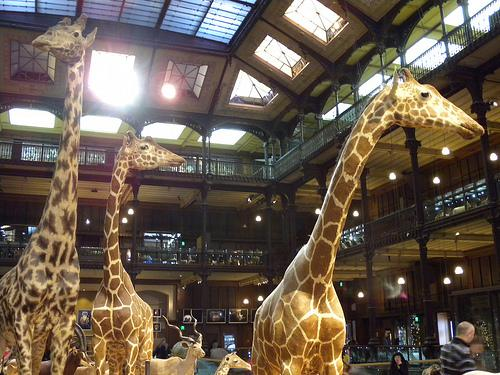Question: what design are the giraffes covered in?
Choices:
A. Spots.
B. Stripes.
C. Polka Dots.
D. Solid.
Answer with the letter. Answer: A Question: how many giraffes are in this photo?
Choices:
A. Three.
B. Two.
C. One.
D. Four.
Answer with the letter. Answer: A Question: why are these giraffes inside a building?
Choices:
A. They sleep there.
B. They eat there.
C. They can get shade there.
D. They aren't real giraffes.
Answer with the letter. Answer: D 